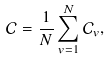Convert formula to latex. <formula><loc_0><loc_0><loc_500><loc_500>\mathcal { C } = \frac { 1 } { N } \sum _ { v = 1 } ^ { N } \mathcal { C } _ { v } ,</formula> 